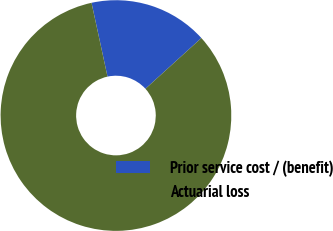<chart> <loc_0><loc_0><loc_500><loc_500><pie_chart><fcel>Prior service cost / (benefit)<fcel>Actuarial loss<nl><fcel>16.67%<fcel>83.33%<nl></chart> 